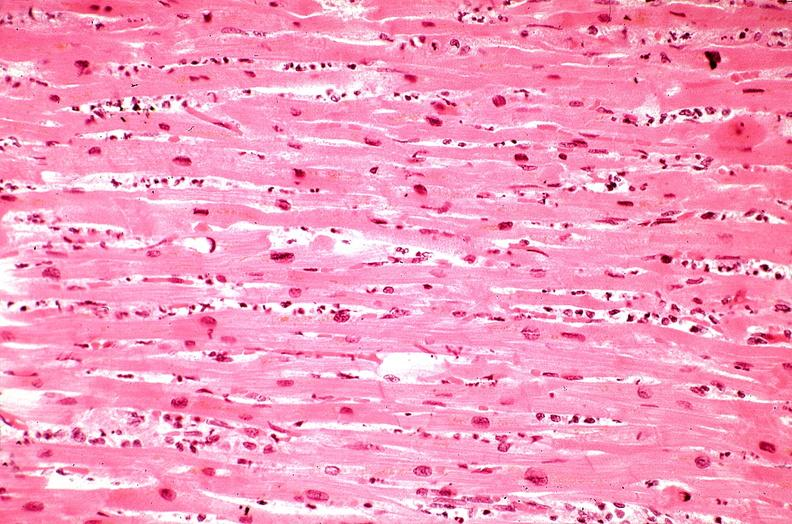what is present?
Answer the question using a single word or phrase. Cardiovascular 